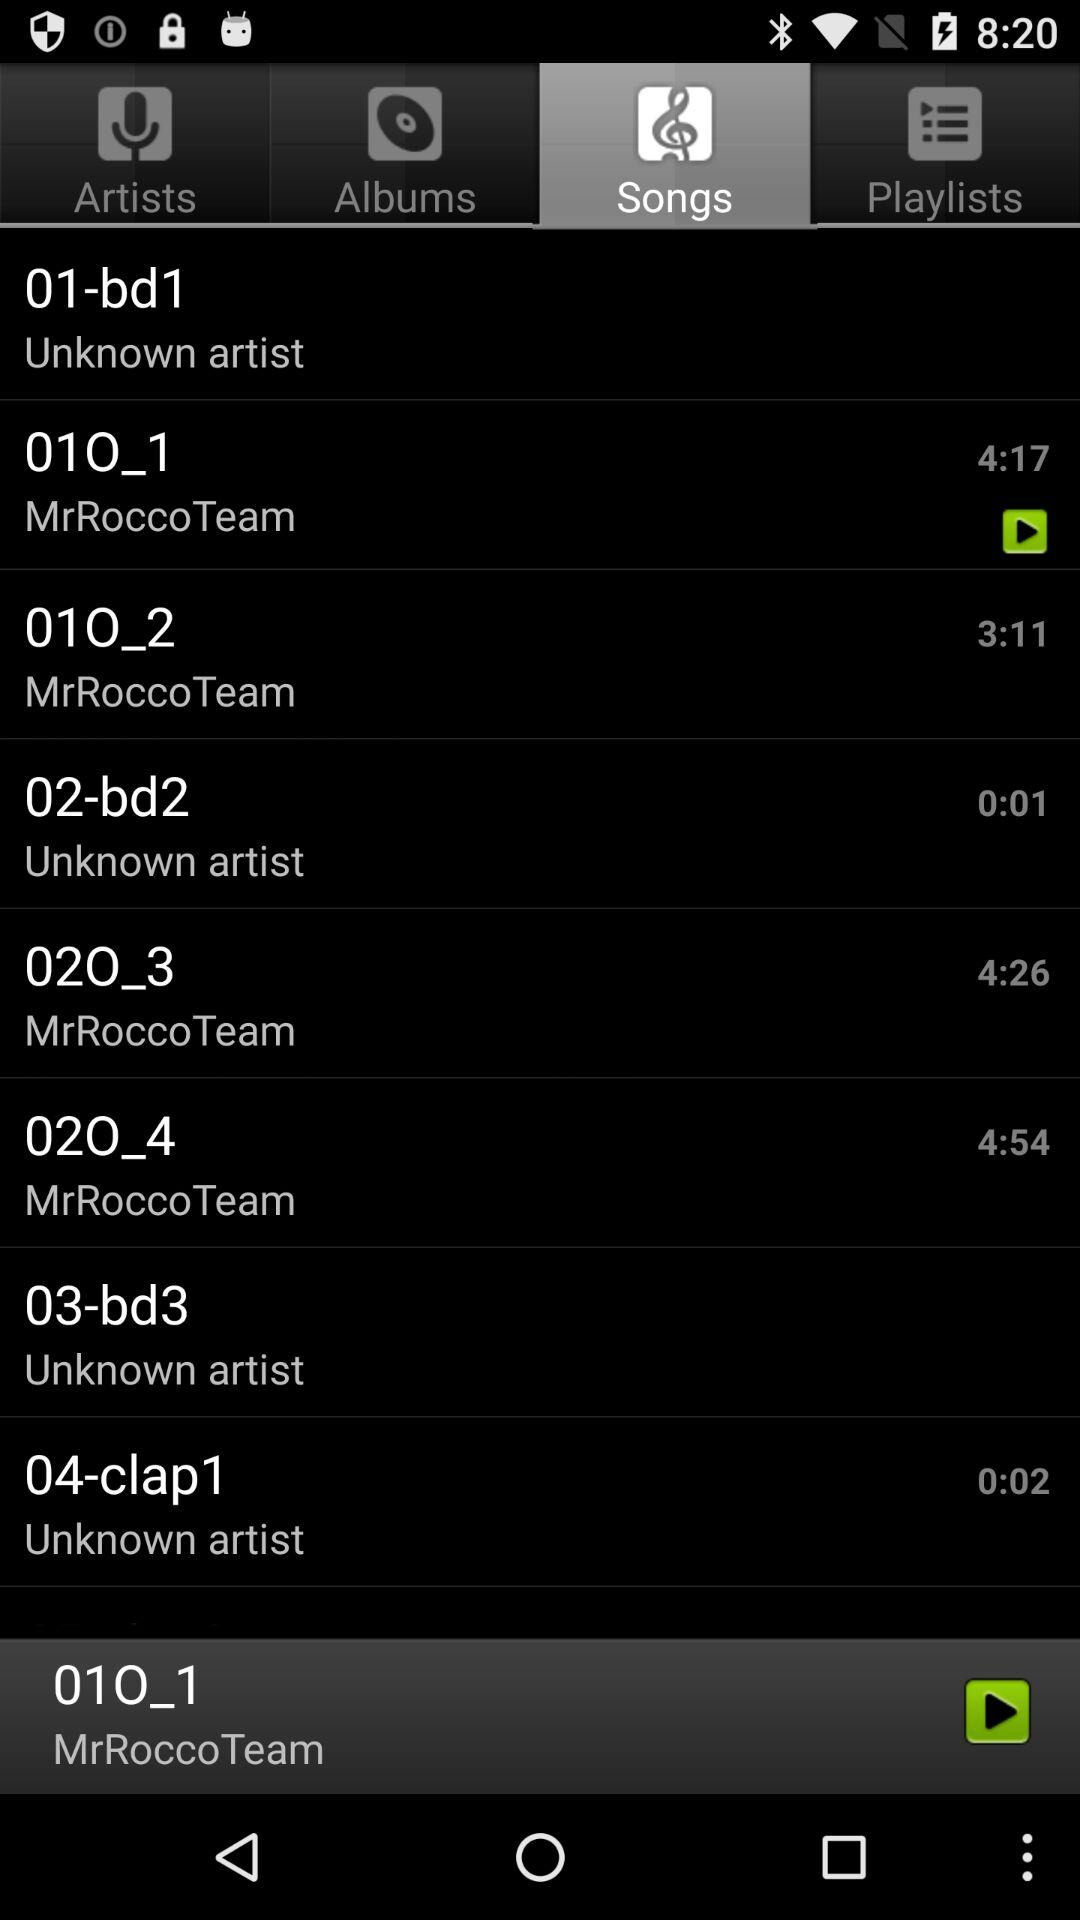What is the name of the artist of the song "02O_3"? The name of the artist is "MrRoccoTeam". 